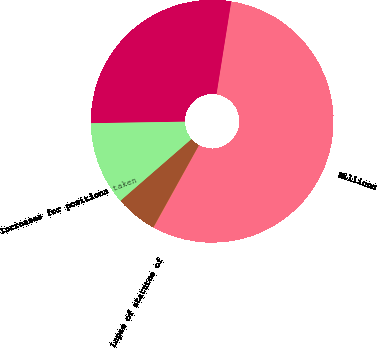<chart> <loc_0><loc_0><loc_500><loc_500><pie_chart><fcel>Millions<fcel>Unrecognized tax benefits at<fcel>Increases for positions taken<fcel>Decreases for positions taken<fcel>Lapse of statutes of<nl><fcel>55.51%<fcel>27.77%<fcel>11.12%<fcel>5.58%<fcel>0.03%<nl></chart> 